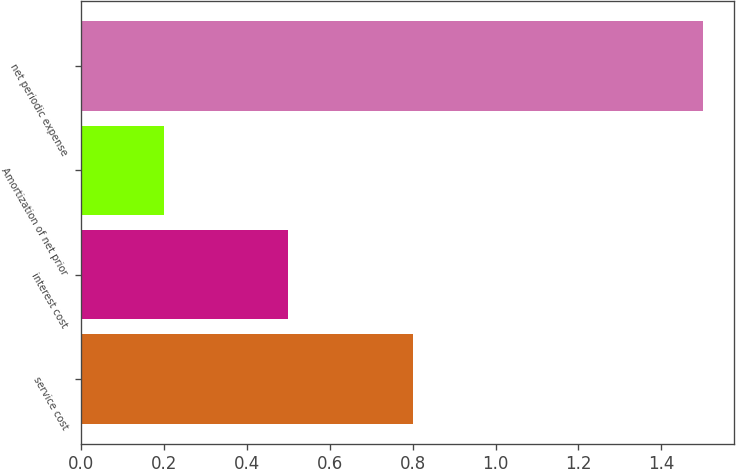Convert chart. <chart><loc_0><loc_0><loc_500><loc_500><bar_chart><fcel>service cost<fcel>interest cost<fcel>Amortization of net prior<fcel>net periodic expense<nl><fcel>0.8<fcel>0.5<fcel>0.2<fcel>1.5<nl></chart> 